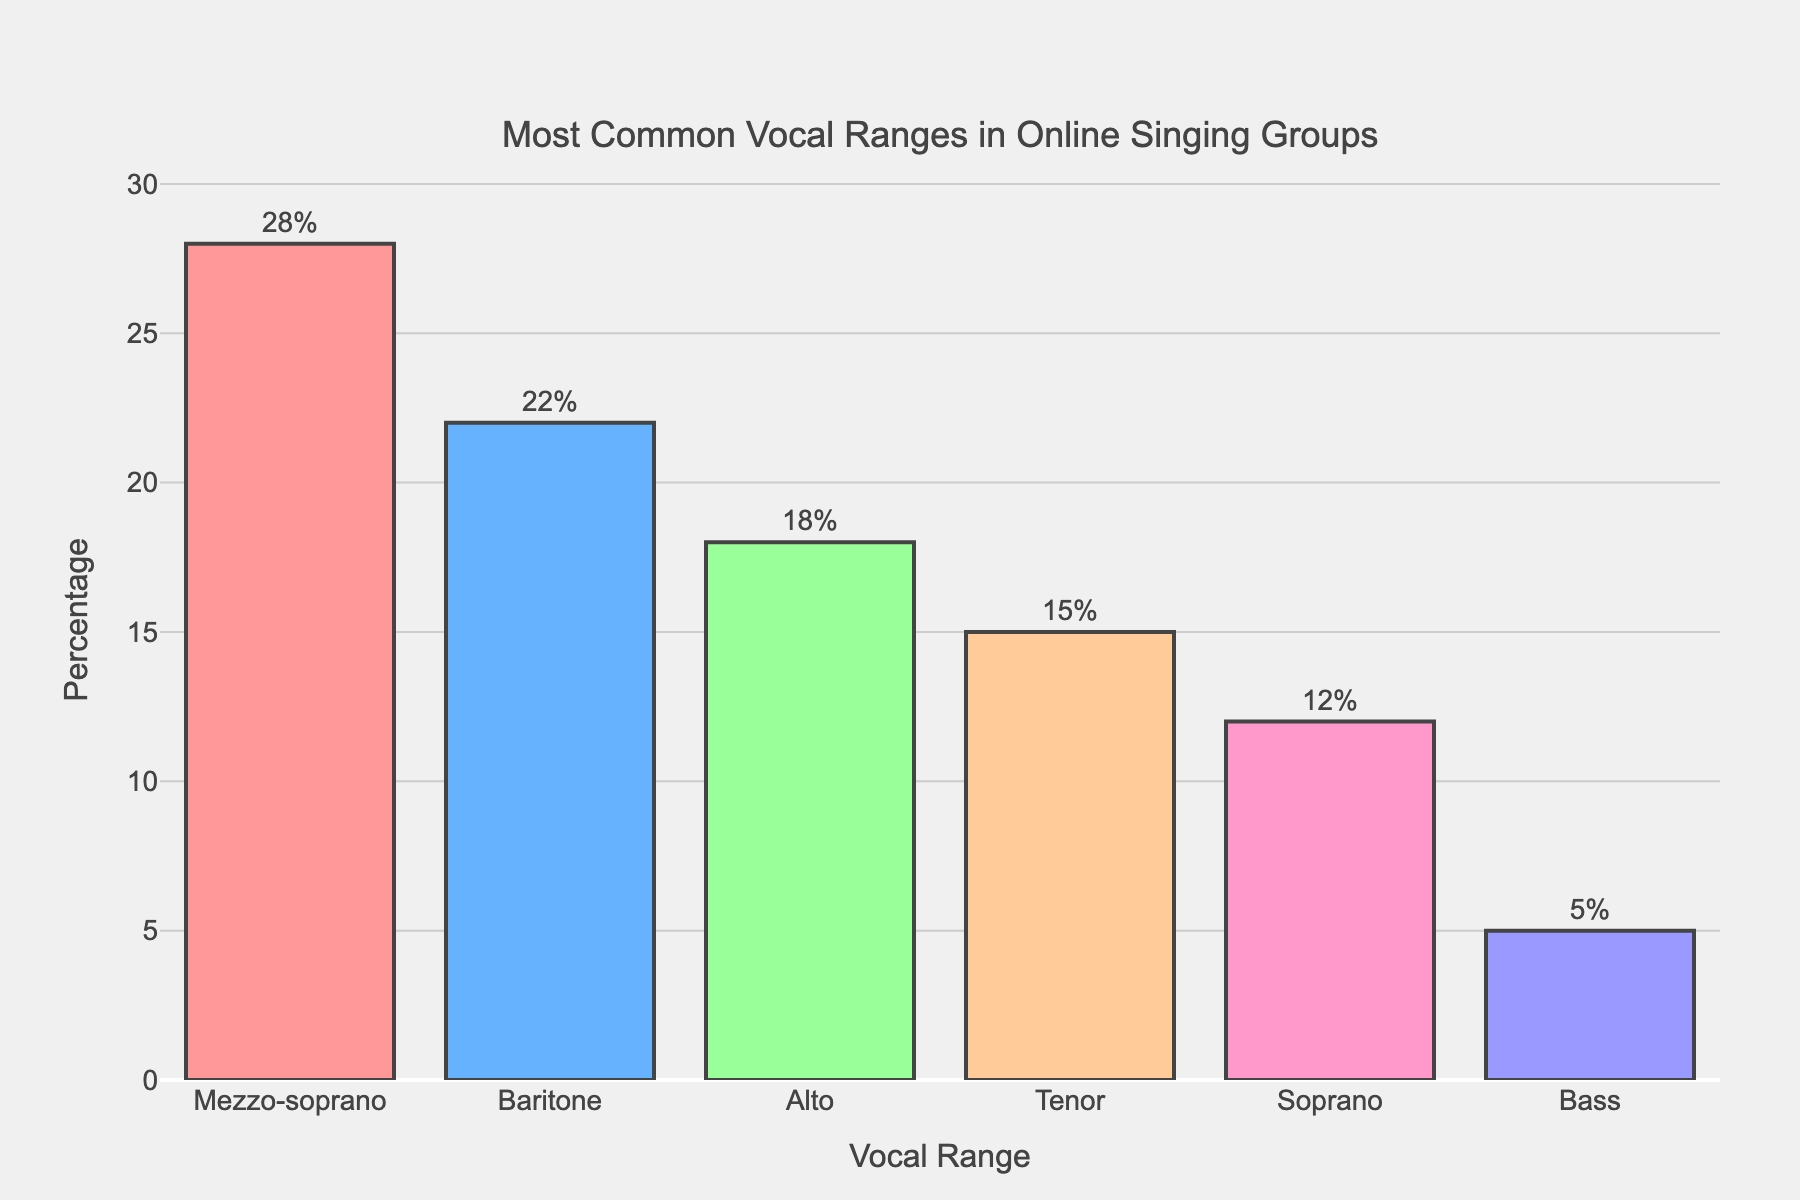What is the most common vocal range among participants in online singing groups? The bar for Mezzo-soprano is the highest, indicating that it has the highest percentage among the vocal ranges. The percentage given at the top of the bar is 28%, which is the highest value.
Answer: Mezzo-soprano Which vocal range has the smallest percentage of participants? The bar for Bass is the shortest, and the percentage indicated at the top of the bar is 5%, which is the smallest value among all vocal ranges.
Answer: Bass How much greater is the percentage of Mezzo-sopranos compared to Basses? The percentage for Mezzo-soprano is 28%, and for Bass, it is 5%. Subtracting the percentage of Bass from Mezzo-soprano gives 28% - 5% = 23%.
Answer: 23% What is the total percentage of participants in the Alto and Tenor vocal ranges? Adding the percentages for Alto and Tenor is 18% + 15%. Performing the addition yields 33%.
Answer: 33% Which is more common, the Soprano or the Tenor vocal range? The percentage for Soprano is 12%, whereas the percentage for Tenor is 15%. Since 15% is greater than 12%, the Tenor vocal range is more common than the Soprano vocal range.
Answer: Tenor Rank the vocal ranges from most common to least common. From the bar height and percentage values given, the order is: Mezzo-soprano (28%), Baritone (22%), Alto (18%), Tenor (15%), Soprano (12%), Bass (5%).
Answer: Mezzo-soprano, Baritone, Alto, Tenor, Soprano, Bass What is the average percentage of participants across all vocal ranges? Add all the percentages and then divide by the number of vocal ranges: (28% + 22% + 18% + 15% + 12% + 5%) / 6. This sums up to 100%, so the average is 100% / 6 = 16.67%.
Answer: 16.67% Which has a higher percentage, the combined Mezzo-soprano and Baritone or the combined Alto and Tenor? Combining Mezzo-soprano and Baritone gives 28% + 22% = 50%. Combining Alto and Tenor gives 18% + 15% = 33%. 50% is greater than 33%, so Mezzo-soprano and Baritone together have a higher percentage.
Answer: Mezzo-soprano and Baritone If Bass participants doubled, what would their new percentage be? Doubling the percentage for Bass (5%) would be 5% * 2 = 10%.
Answer: 10% 